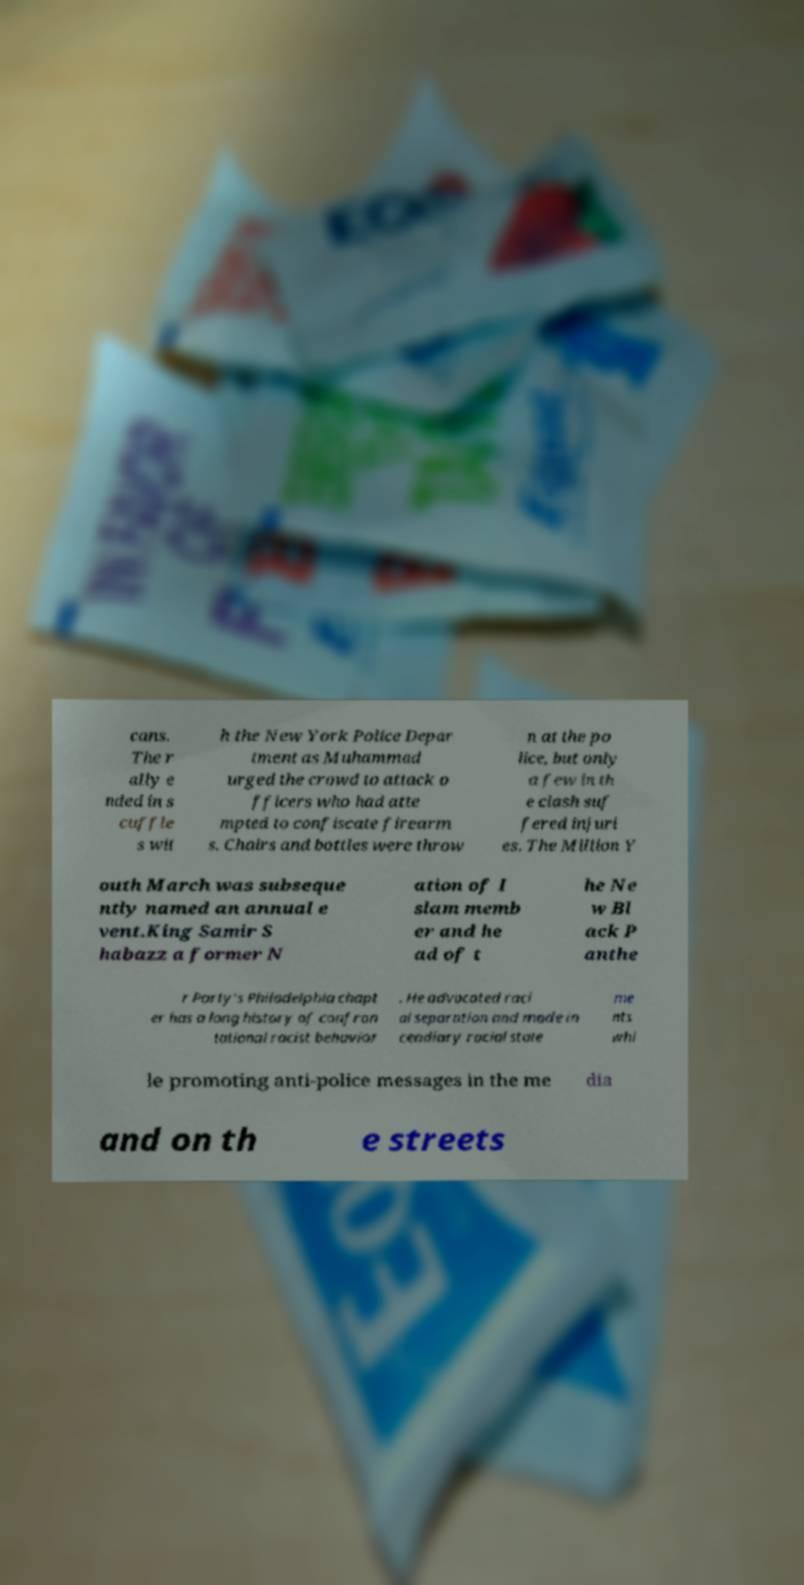Please read and relay the text visible in this image. What does it say? cans. The r ally e nded in s cuffle s wit h the New York Police Depar tment as Muhammad urged the crowd to attack o fficers who had atte mpted to confiscate firearm s. Chairs and bottles were throw n at the po lice, but only a few in th e clash suf fered injuri es. The Million Y outh March was subseque ntly named an annual e vent.King Samir S habazz a former N ation of I slam memb er and he ad of t he Ne w Bl ack P anthe r Party's Philadelphia chapt er has a long history of confron tational racist behavior . He advocated raci al separation and made in cendiary racial state me nts whi le promoting anti-police messages in the me dia and on th e streets 